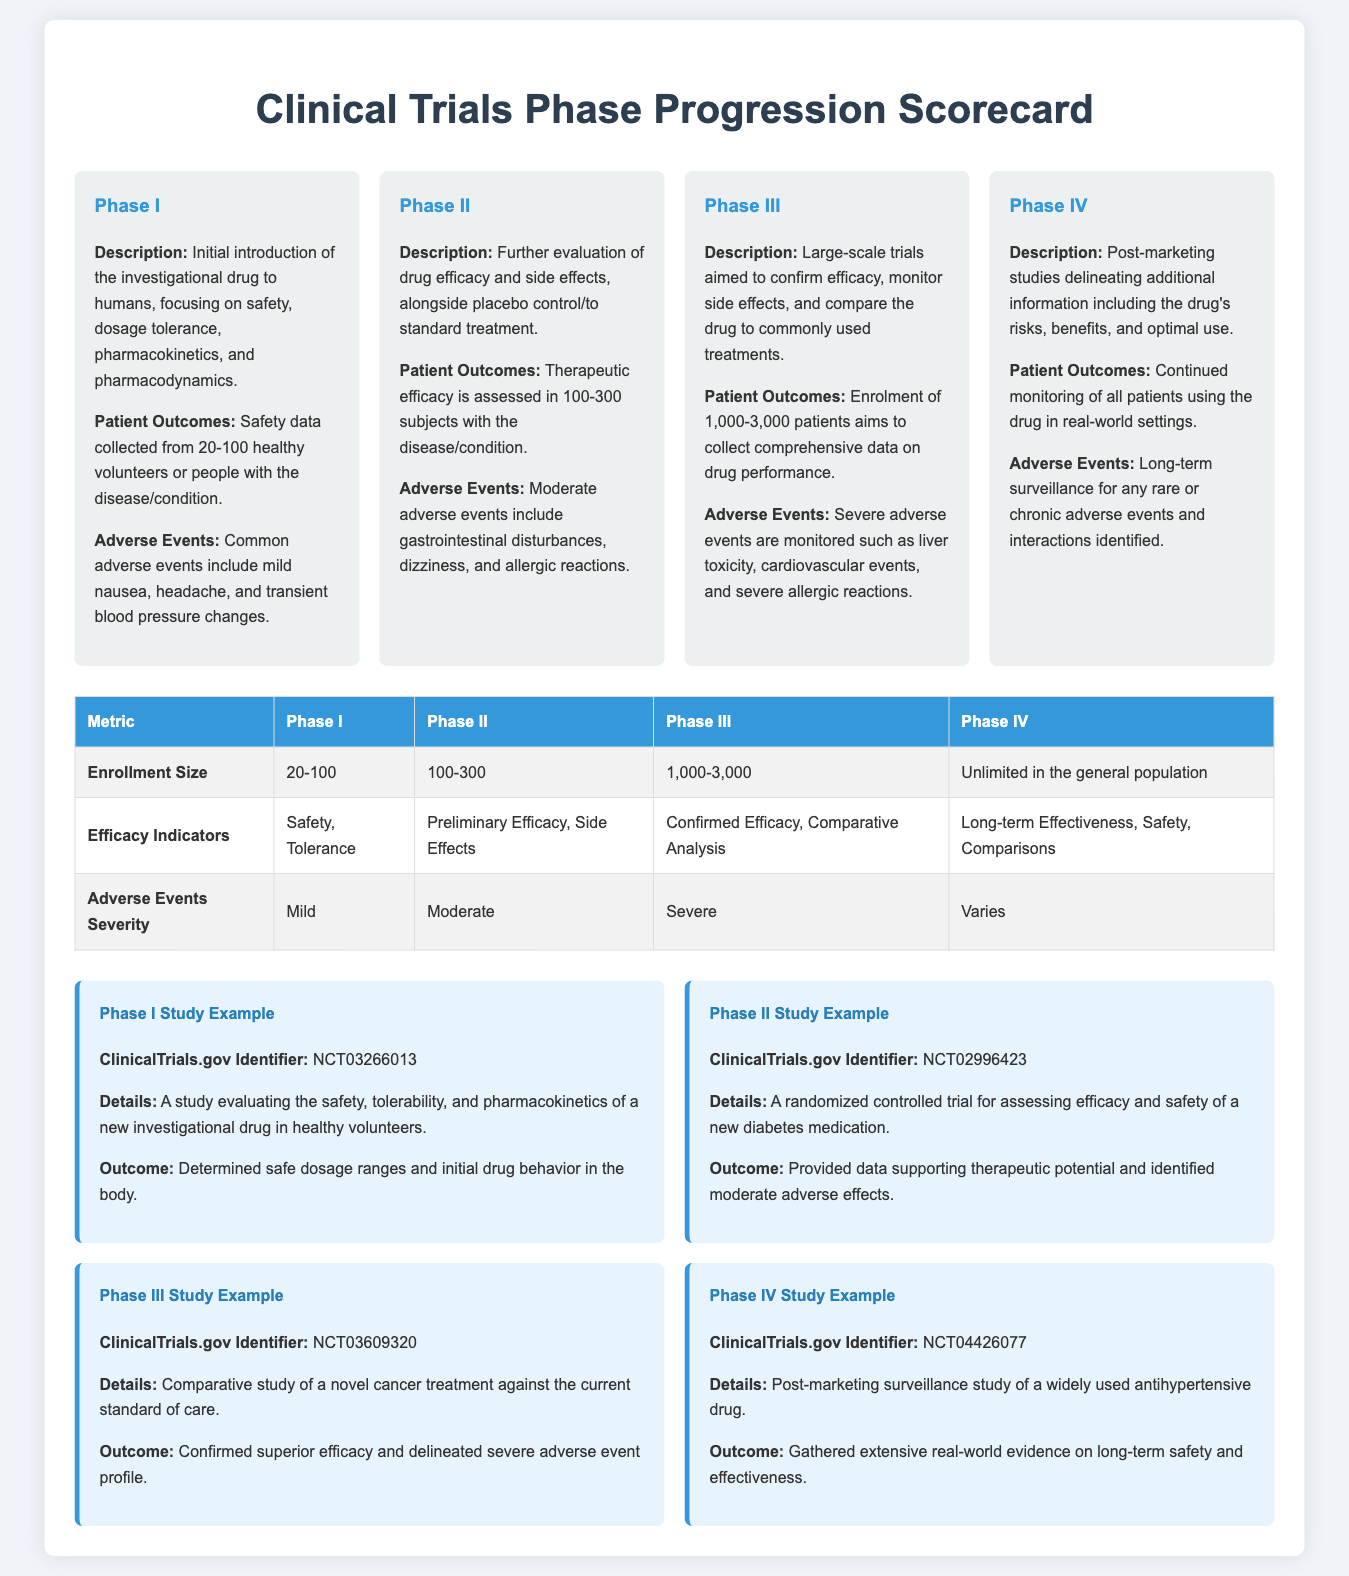What is the enrollment size in Phase I? The enrollment size in Phase I ranges from 20 to 100 subjects as outlined in the metrics table.
Answer: 20-100 What are the common adverse events in Phase II? The document specifies that moderate adverse events in Phase II include gastrointestinal disturbances, dizziness, and allergic reactions.
Answer: Gastrointestinal disturbances, dizziness, and allergic reactions What is the main focus of Phase III trials? Phase III trials primarily aim to confirm efficacy, monitor side effects, and compare the drug to standard treatments, according to the description provided.
Answer: Confirm efficacy, monitor side effects, compare to standard treatments How many patients are enrolled in Phase IV studies? The document states that Phase IV studies have unlimited enrollment in the general population.
Answer: Unlimited What type of study is referenced in the example for Phase I? The example for Phase I refers to a study evaluating safety, tolerability, and pharmacokinetics in healthy volunteers.
Answer: Safety, tolerability, and pharmacokinetics What does the adverse events severity escalate to in Phase III? According to the metrics table, the severity of adverse events escalates to severe in Phase III trials.
Answer: Severe What are the efficacy indicators for Phase II? The document notes that the efficacy indicators in Phase II include preliminary efficacy and side effects, as detailed in the metrics table.
Answer: Preliminary Efficacy, Side Effects What does Phase IV focus on after marketing? Phase IV focuses on post-marketing studies to delineate additional information regarding the drug's risks, benefits, and optimal use.
Answer: Risks, benefits, and optimal use What is the ClinicalTrials.gov Identifier for the Phase III study example? The Phase III study example has the ClinicalTrials.gov Identifier NCT03609320, as noted in the document.
Answer: NCT03609320 